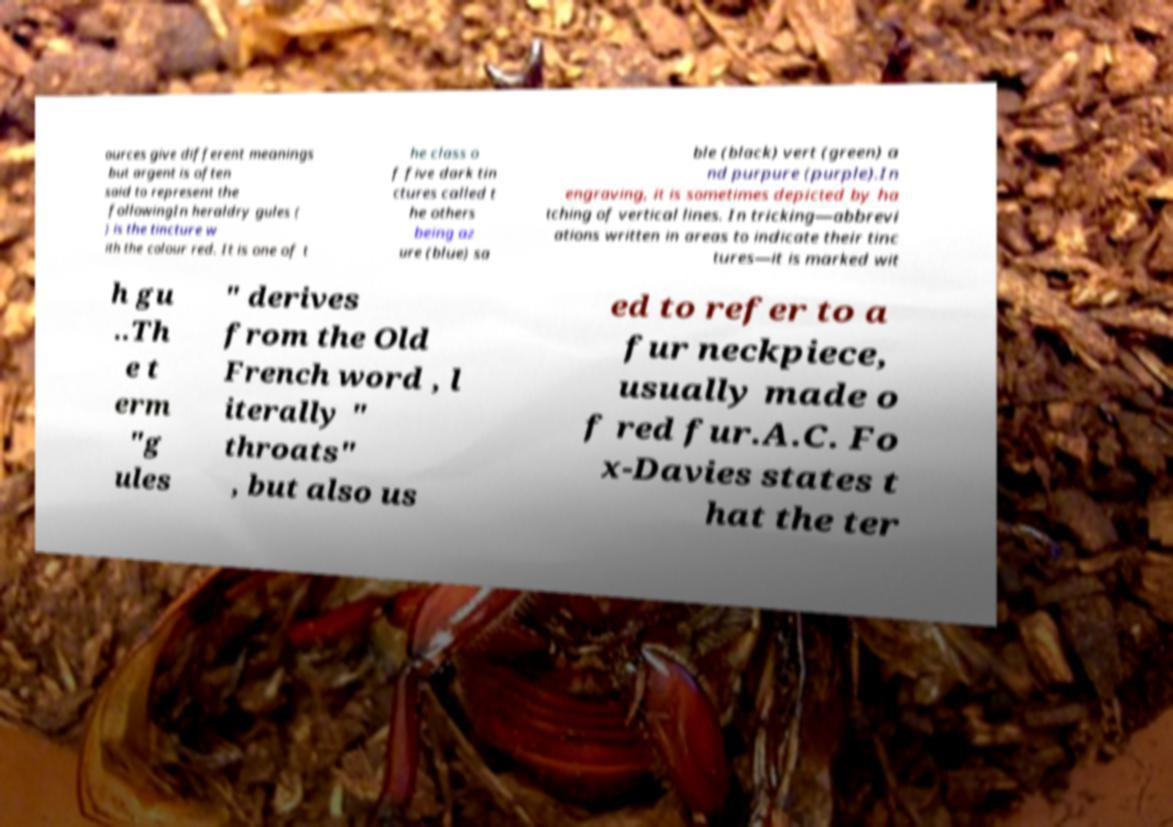Please read and relay the text visible in this image. What does it say? ources give different meanings but argent is often said to represent the followingIn heraldry gules ( ) is the tincture w ith the colour red. It is one of t he class o f five dark tin ctures called t he others being az ure (blue) sa ble (black) vert (green) a nd purpure (purple).In engraving, it is sometimes depicted by ha tching of vertical lines. In tricking—abbrevi ations written in areas to indicate their tinc tures—it is marked wit h gu ..Th e t erm "g ules " derives from the Old French word , l iterally " throats" , but also us ed to refer to a fur neckpiece, usually made o f red fur.A.C. Fo x-Davies states t hat the ter 